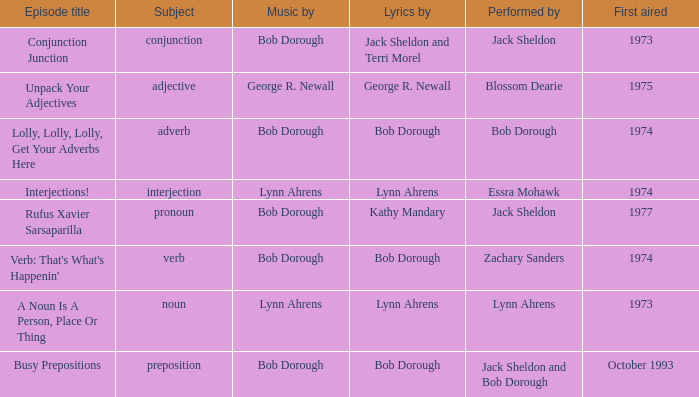How many performers are involved when the subject is an interjection? 1.0. 